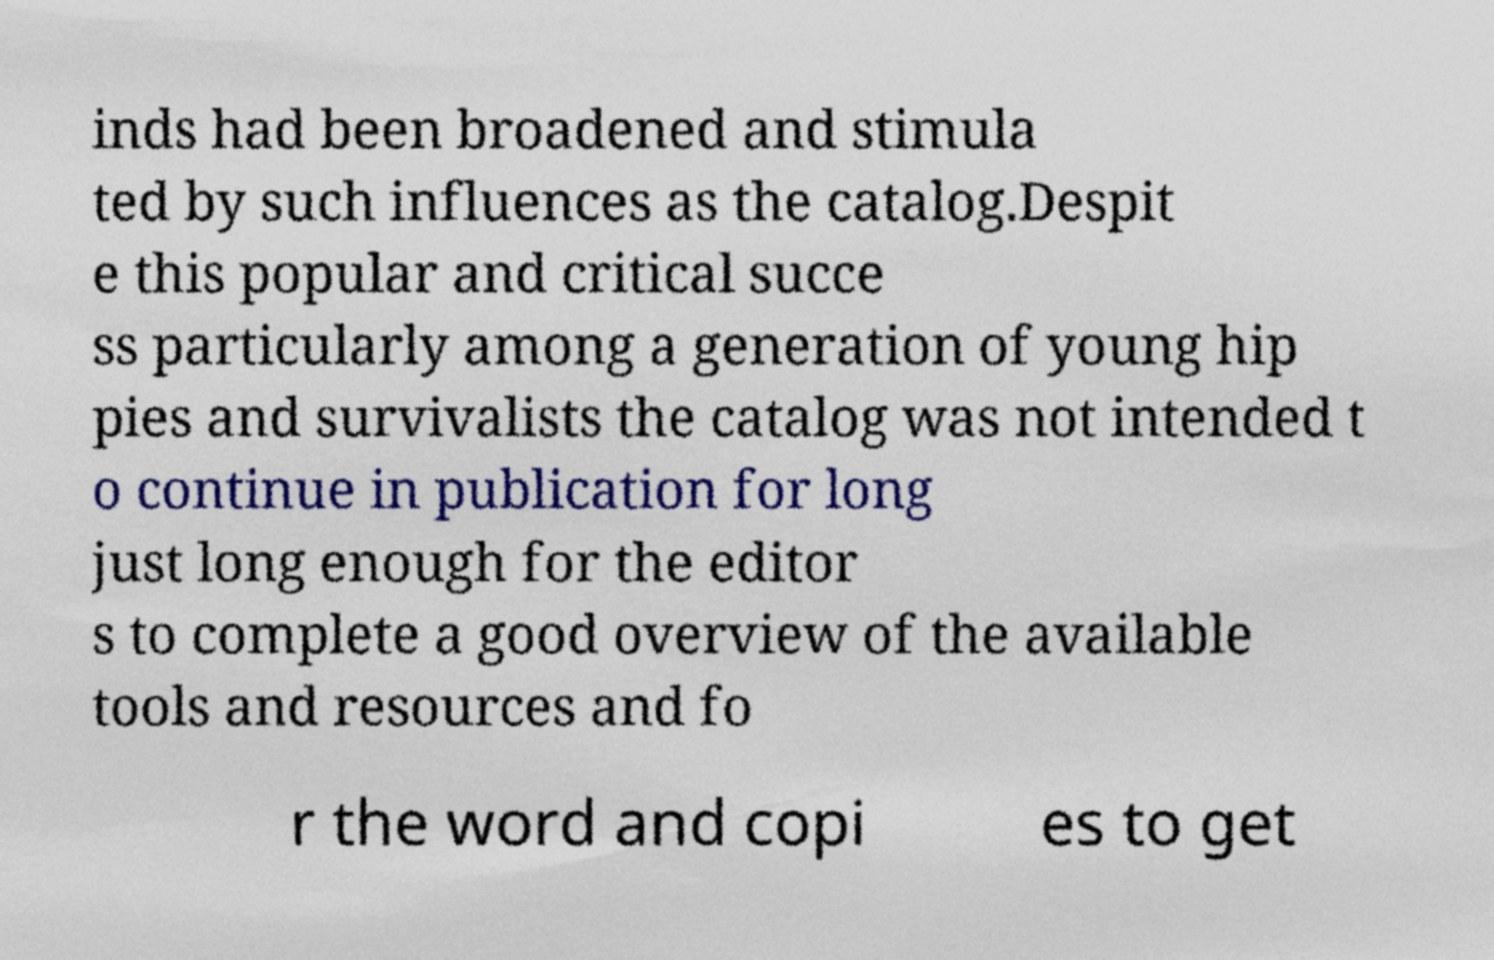For documentation purposes, I need the text within this image transcribed. Could you provide that? inds had been broadened and stimula ted by such influences as the catalog.Despit e this popular and critical succe ss particularly among a generation of young hip pies and survivalists the catalog was not intended t o continue in publication for long just long enough for the editor s to complete a good overview of the available tools and resources and fo r the word and copi es to get 